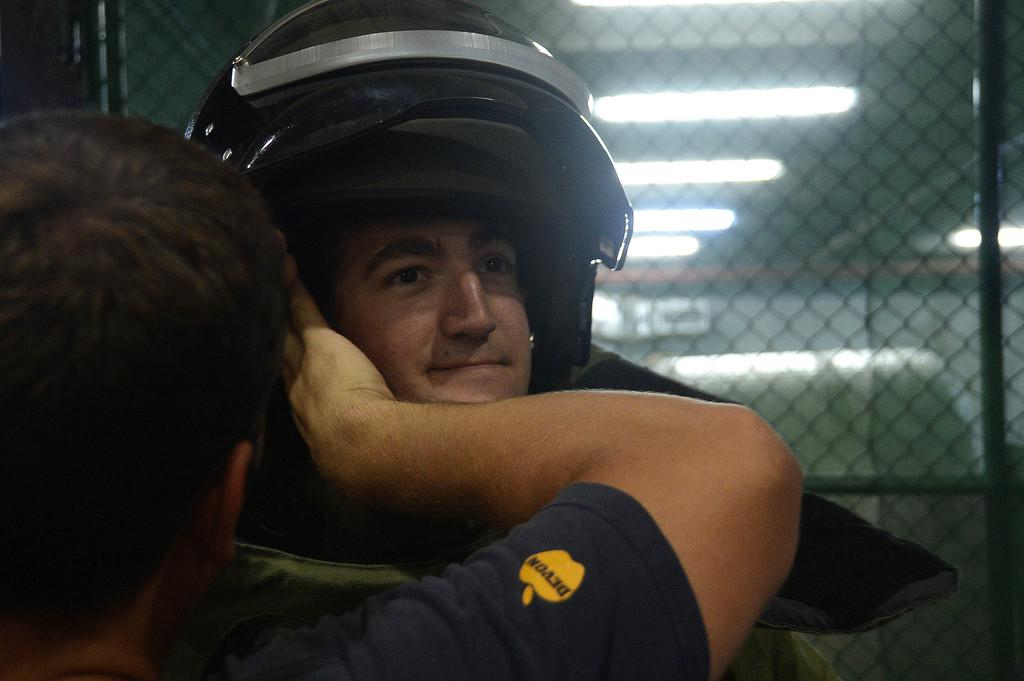How many people are in the image? There are two men in the image. What is one person doing to the other person? One person is putting a helmet on the other person. What can be seen in the background of the image? There are lights, a wall, and other objects in the background of the image. What is in the center of the image? There is a fencing in the center of the image. What type of necklace is the woman wearing in the image? There is no woman present in the image, and therefore no necklace can be observed. What type of tank is visible in the image? There is no tank present in the image. 